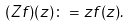<formula> <loc_0><loc_0><loc_500><loc_500>( Z f ) ( z ) \colon = z f ( z ) .</formula> 